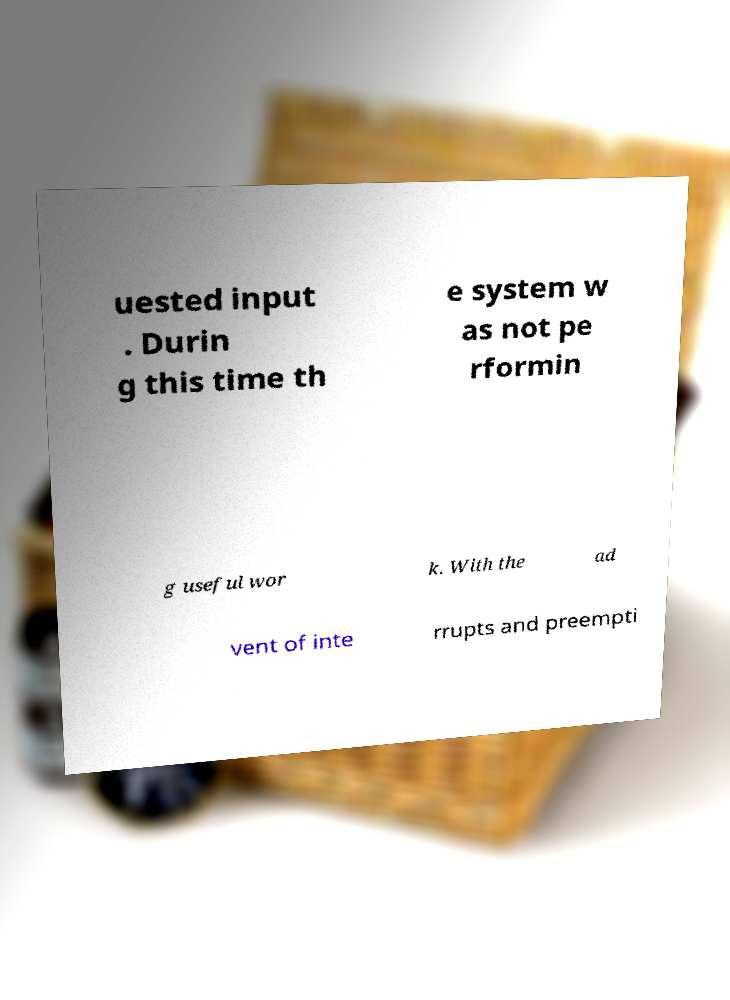Could you assist in decoding the text presented in this image and type it out clearly? uested input . Durin g this time th e system w as not pe rformin g useful wor k. With the ad vent of inte rrupts and preempti 